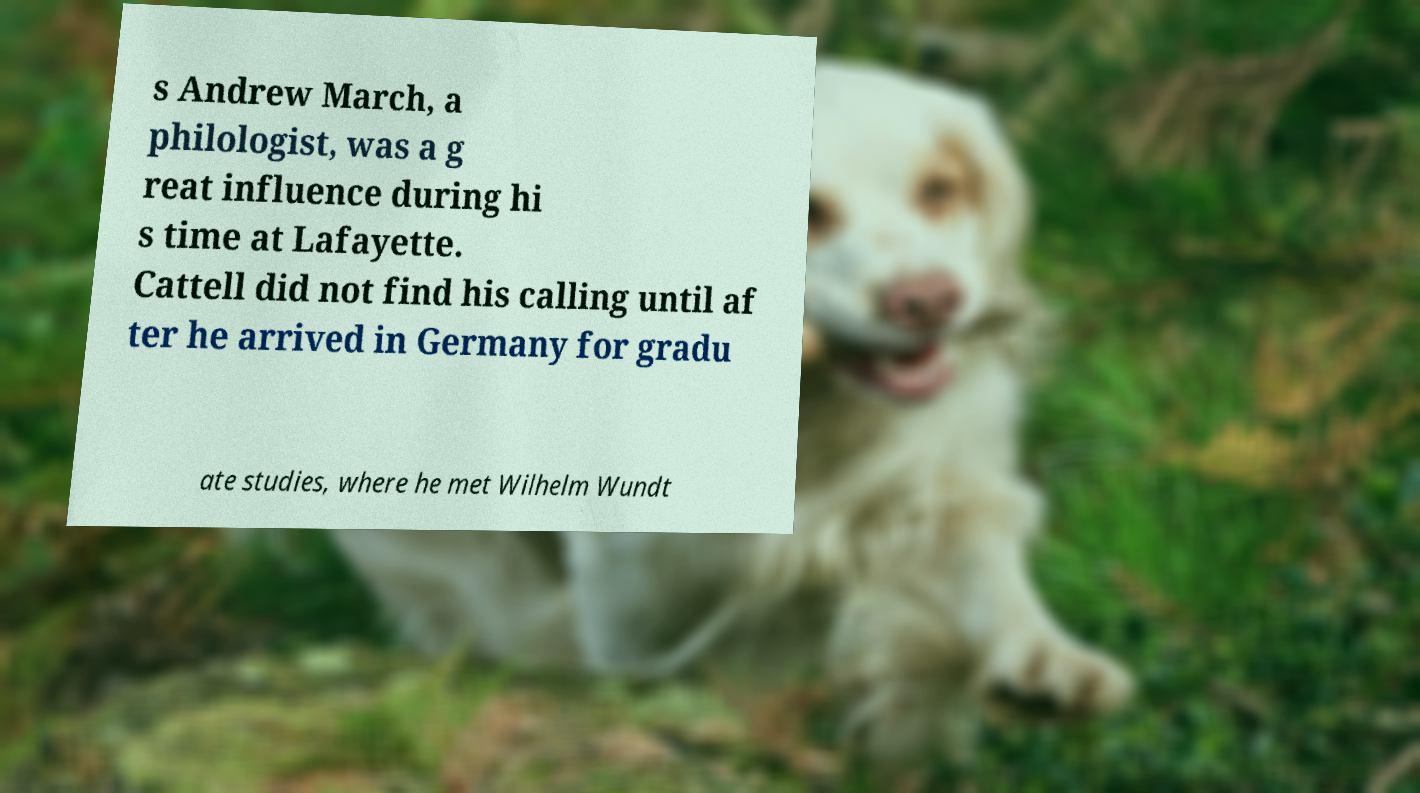Can you read and provide the text displayed in the image?This photo seems to have some interesting text. Can you extract and type it out for me? s Andrew March, a philologist, was a g reat influence during hi s time at Lafayette. Cattell did not find his calling until af ter he arrived in Germany for gradu ate studies, where he met Wilhelm Wundt 